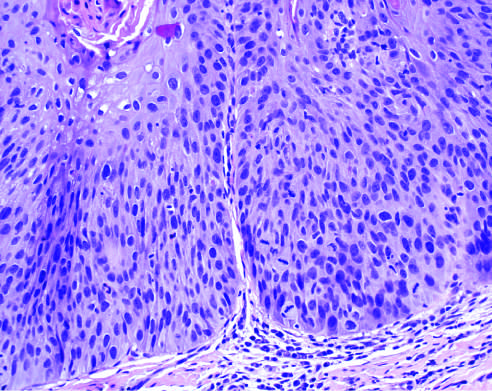s histologic appearance of leukoplakia showing dysplasia characterized by nuclear and cellular pleomorphism and loss of normal maturation?
Answer the question using a single word or phrase. Yes 